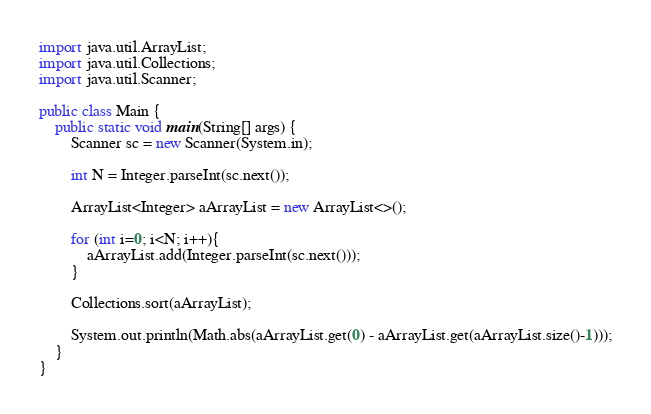<code> <loc_0><loc_0><loc_500><loc_500><_Java_>import java.util.ArrayList;
import java.util.Collections;
import java.util.Scanner;

public class Main {
	public static void main(String[] args) {
		Scanner sc = new Scanner(System.in);

		int N = Integer.parseInt(sc.next());

		ArrayList<Integer> aArrayList = new ArrayList<>();

		for (int i=0; i<N; i++){
			aArrayList.add(Integer.parseInt(sc.next()));
		}

		Collections.sort(aArrayList);

		System.out.println(Math.abs(aArrayList.get(0) - aArrayList.get(aArrayList.size()-1)));
	}
}
</code> 